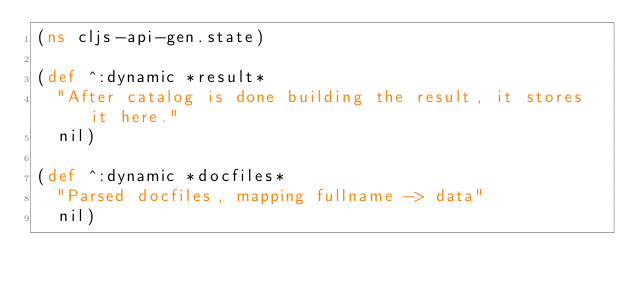<code> <loc_0><loc_0><loc_500><loc_500><_Clojure_>(ns cljs-api-gen.state)

(def ^:dynamic *result*
  "After catalog is done building the result, it stores it here."
  nil)

(def ^:dynamic *docfiles*
  "Parsed docfiles, mapping fullname -> data"
  nil)
</code> 